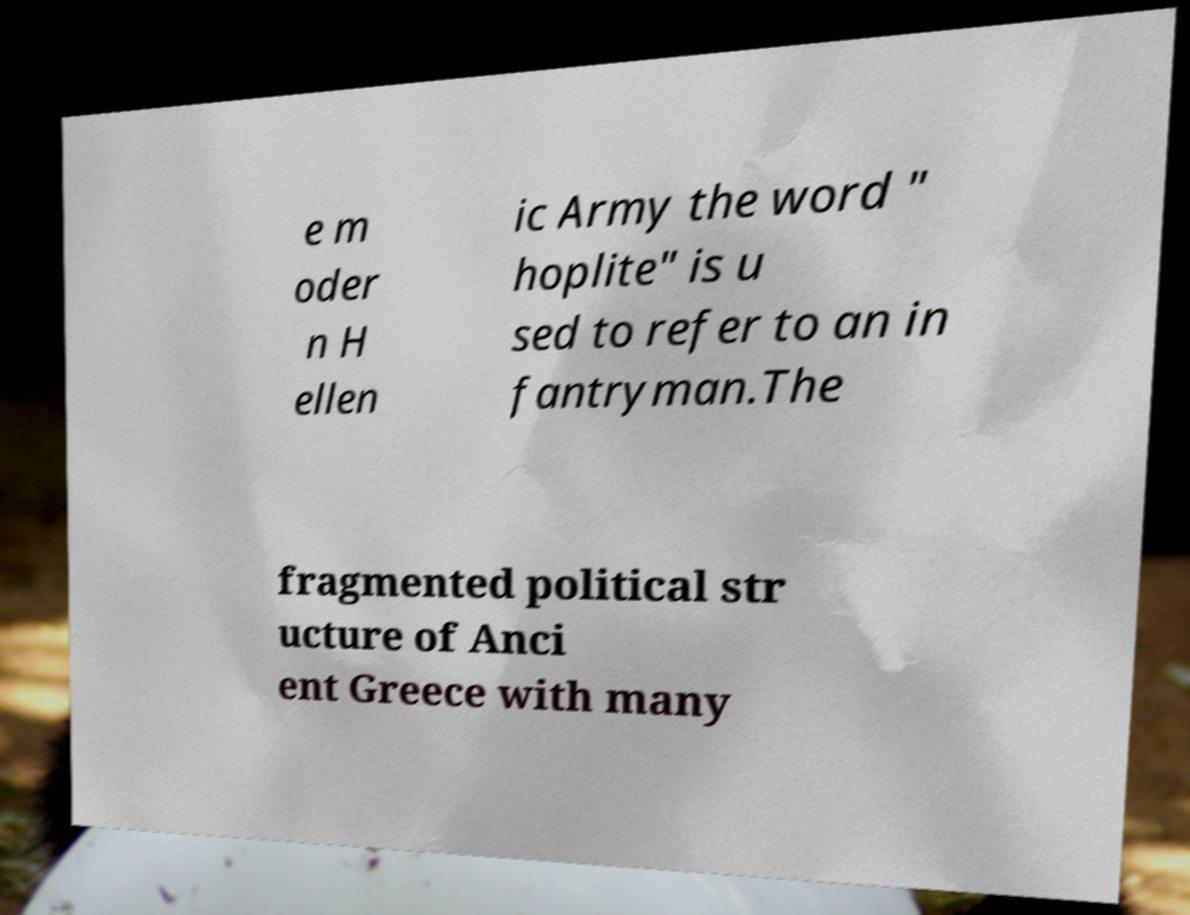What messages or text are displayed in this image? I need them in a readable, typed format. e m oder n H ellen ic Army the word " hoplite" is u sed to refer to an in fantryman.The fragmented political str ucture of Anci ent Greece with many 